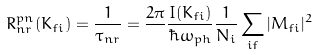<formula> <loc_0><loc_0><loc_500><loc_500>R ^ { p n } _ { n r } ( K _ { f i } ) = \frac { 1 } { \tau _ { n r } } = \frac { 2 \pi } { } \frac { I ( K _ { f i } ) } { \hbar { \omega } _ { p h } } \frac { 1 } { N _ { i } } \sum _ { i f } | M _ { f i } | ^ { 2 }</formula> 